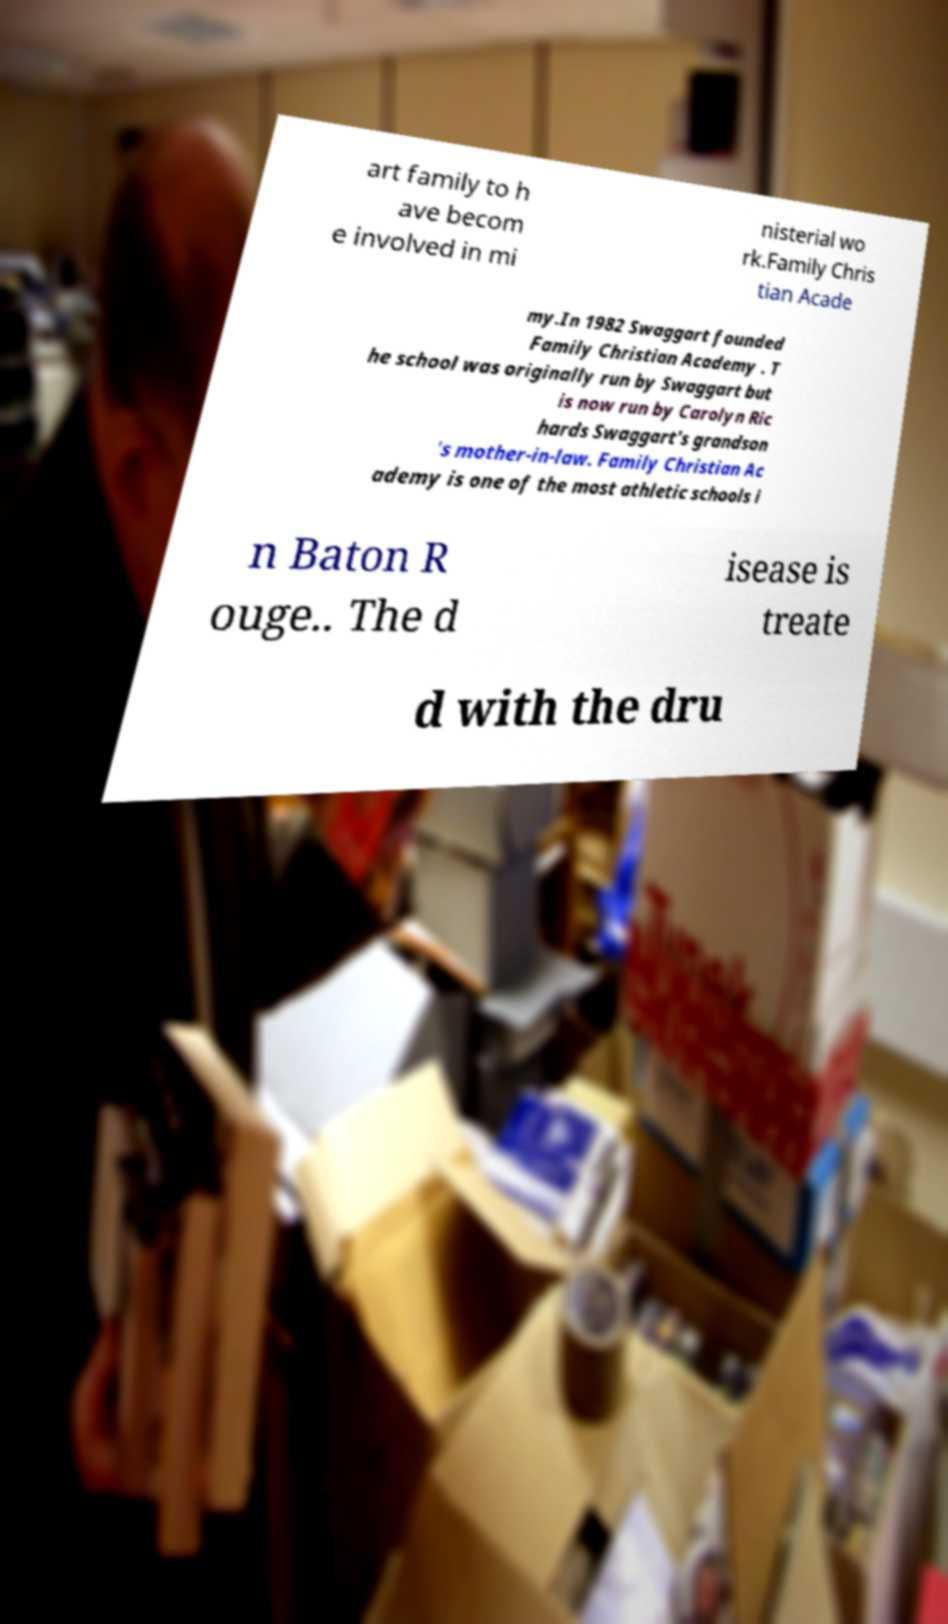For documentation purposes, I need the text within this image transcribed. Could you provide that? art family to h ave becom e involved in mi nisterial wo rk.Family Chris tian Acade my.In 1982 Swaggart founded Family Christian Academy . T he school was originally run by Swaggart but is now run by Carolyn Ric hards Swaggart's grandson 's mother-in-law. Family Christian Ac ademy is one of the most athletic schools i n Baton R ouge.. The d isease is treate d with the dru 